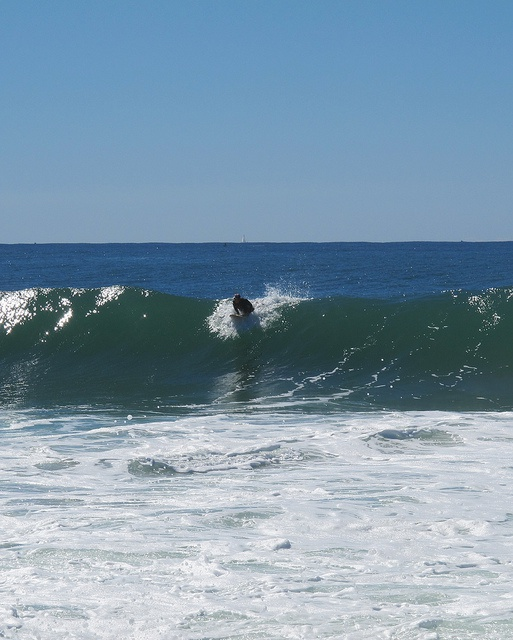Describe the objects in this image and their specific colors. I can see people in gray and black tones and surfboard in gray, black, and darkgray tones in this image. 